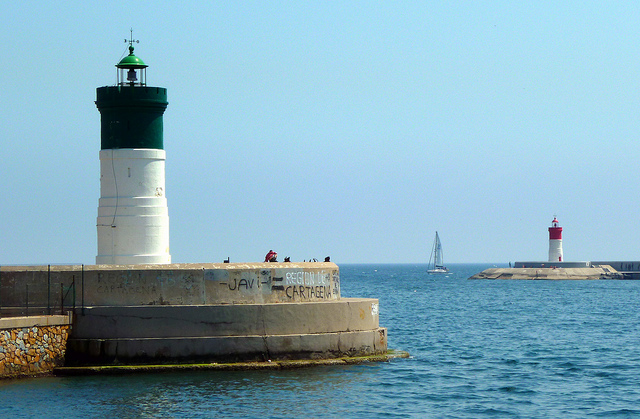What colors are the lighthouses? The lighthouse closest to us has a white base and a green top, while the one in the distance has distinctive red and white stripes. 